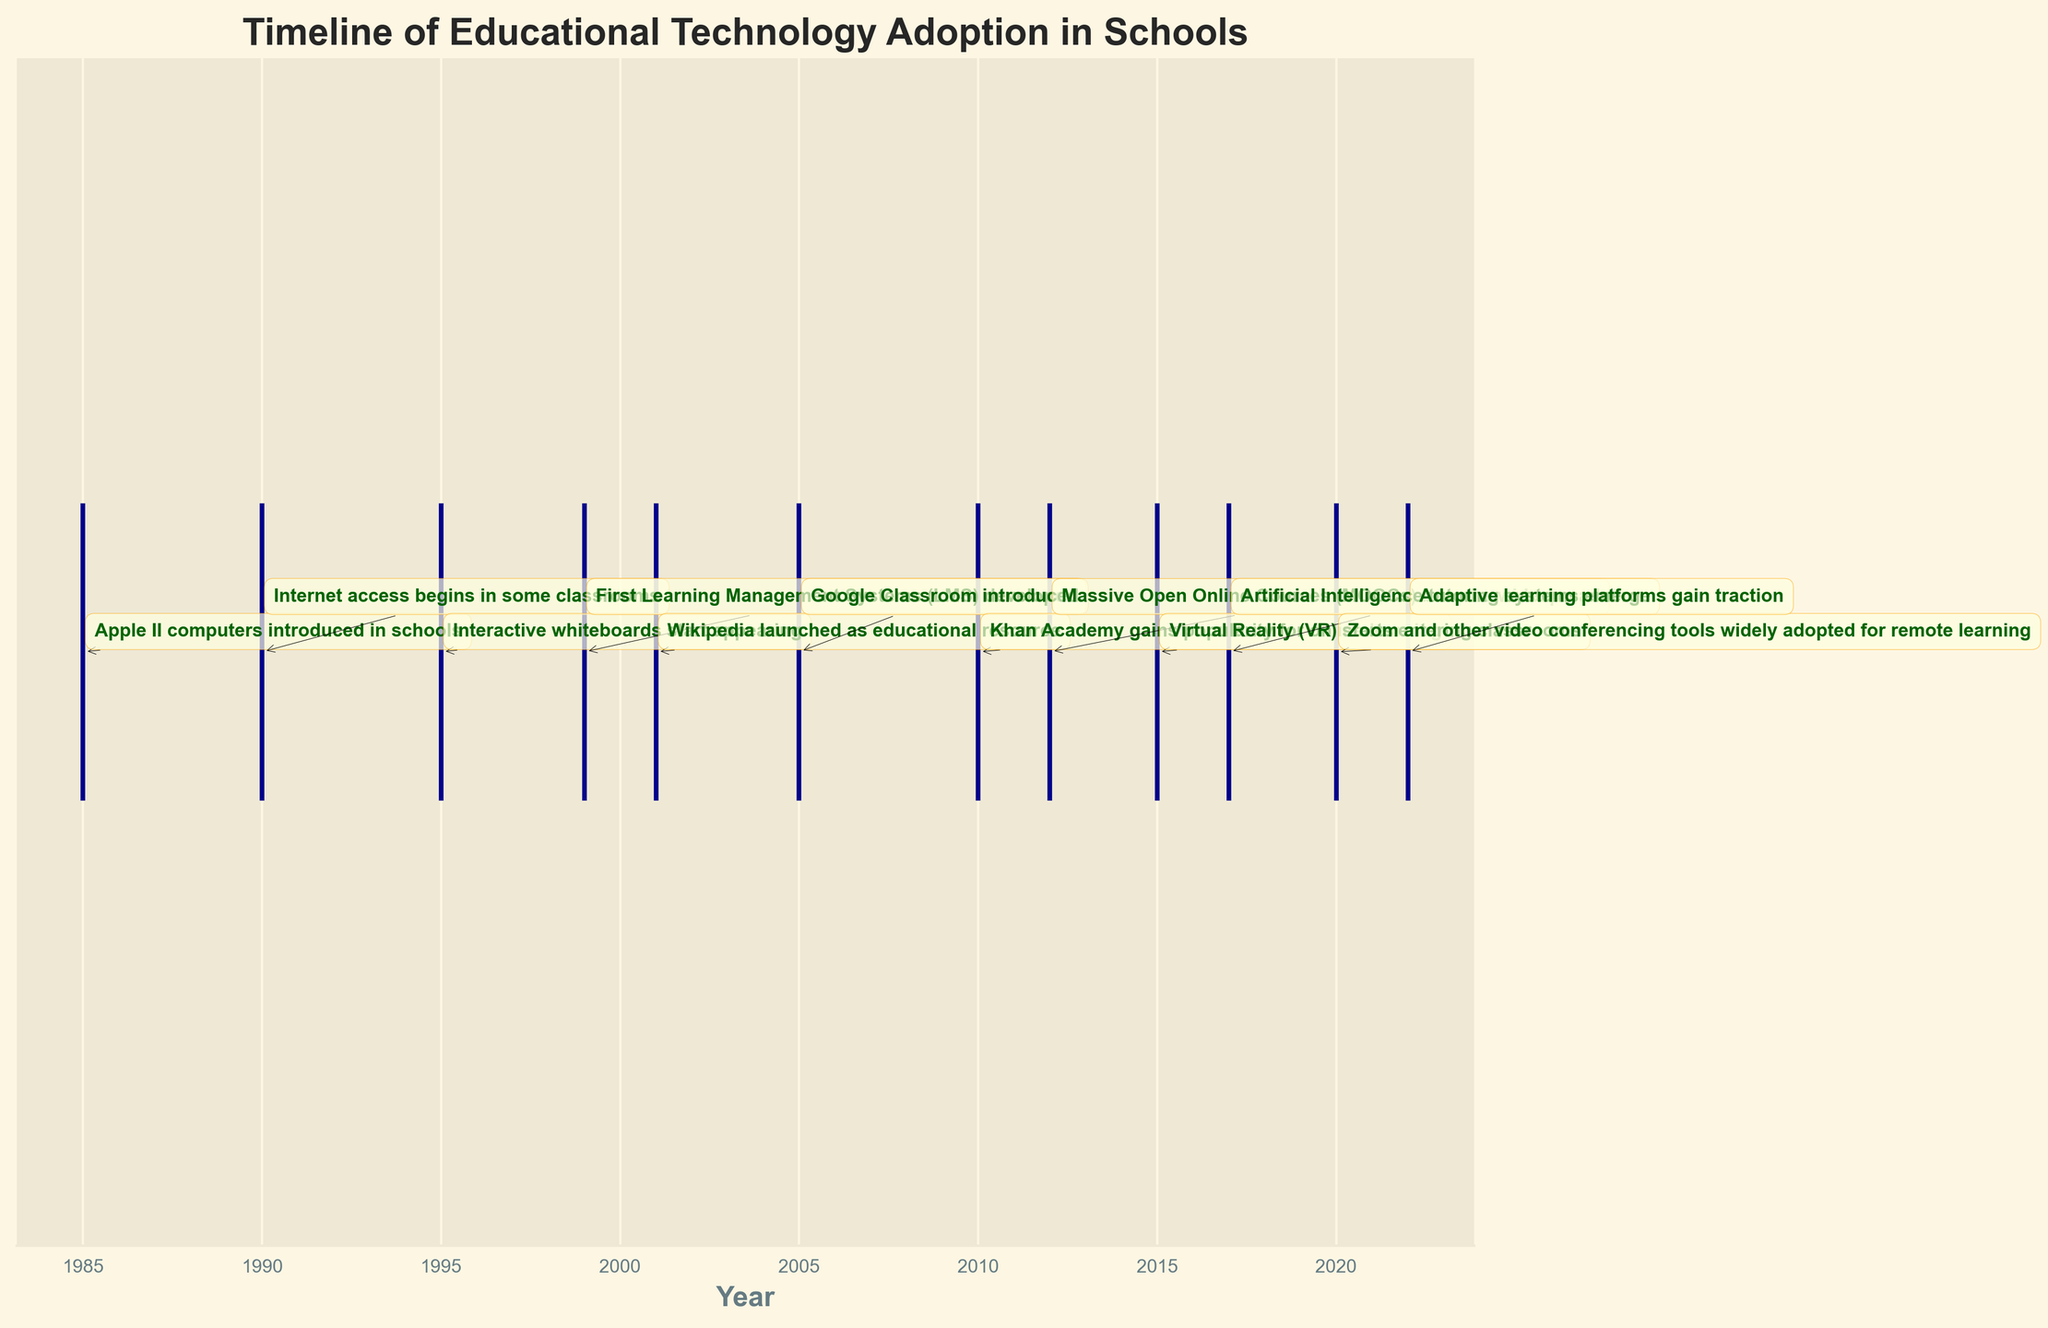When was the Apple II computer introduced in schools? The eventplot shows the timeline of educational technology, with the Apple II computers introduced in the year 1985. This is the earliest event on the timeline.
Answer: 1985 Which year did Wikipedia launch as an educational resource? By inspecting the eventplot, we can see an annotated event labeled "Wikipedia launched as educational resource" positioned at the year 2001.
Answer: 2001 What is the total number of significant events marked on the timeline? The eventplot includes marked events for every significant educational technology adoption from 1985 to 2022. By counting the annotated events on the plot, there are 12 events.
Answer: 12 Compare the years of introduction for the first Learning Management Systems (LMS) and Khan Academy. Which came first? The eventplot indicates that the first Learning Management Systems (LMS) were developed in 1999, and Khan Academy gained popularity for online learning in 2010. Hence, LMS was introduced earlier.
Answer: LMS What range of years does the timeline cover for educational technology adoption? The timeline starts with the year 1985 and ends with 2022. By identifying these years from the first and last annotations on the plot, the range is determined.
Answer: 1985 to 2022 Calculate the difference in years between the introduction of Google Classroom and the widespread adoption of MOOCs. Google Classroom was introduced in 2005, and MOOCs became widespread in 2012. Subtracting these years gives a result of 2012 - 2005 = 7 years.
Answer: 7 years Which technology adoption event occurred most recently? By looking at the timeline, the most recent event is "Adaptive learning platforms gain traction" in the year 2022.
Answer: Adaptive learning platforms gain traction What is unique about the labeling of events in the eventplot? The labels are annotated with a specific combination of font style and text box styling, placed adjacent to the year on the timeline. This helps clearly depict each event's occurrence.
Answer: Unique font style and text box styling Identify and list any two significant technological innovations incorporated into classrooms after 2010. According to the eventplot, after 2010, Virtual Reality (VR) started entering classrooms in 2015, and Artificial Intelligence tutoring systems emerged in 2017.
Answer: Virtual Reality (VR) in 2015, Artificial Intelligence tutoring in 2017 